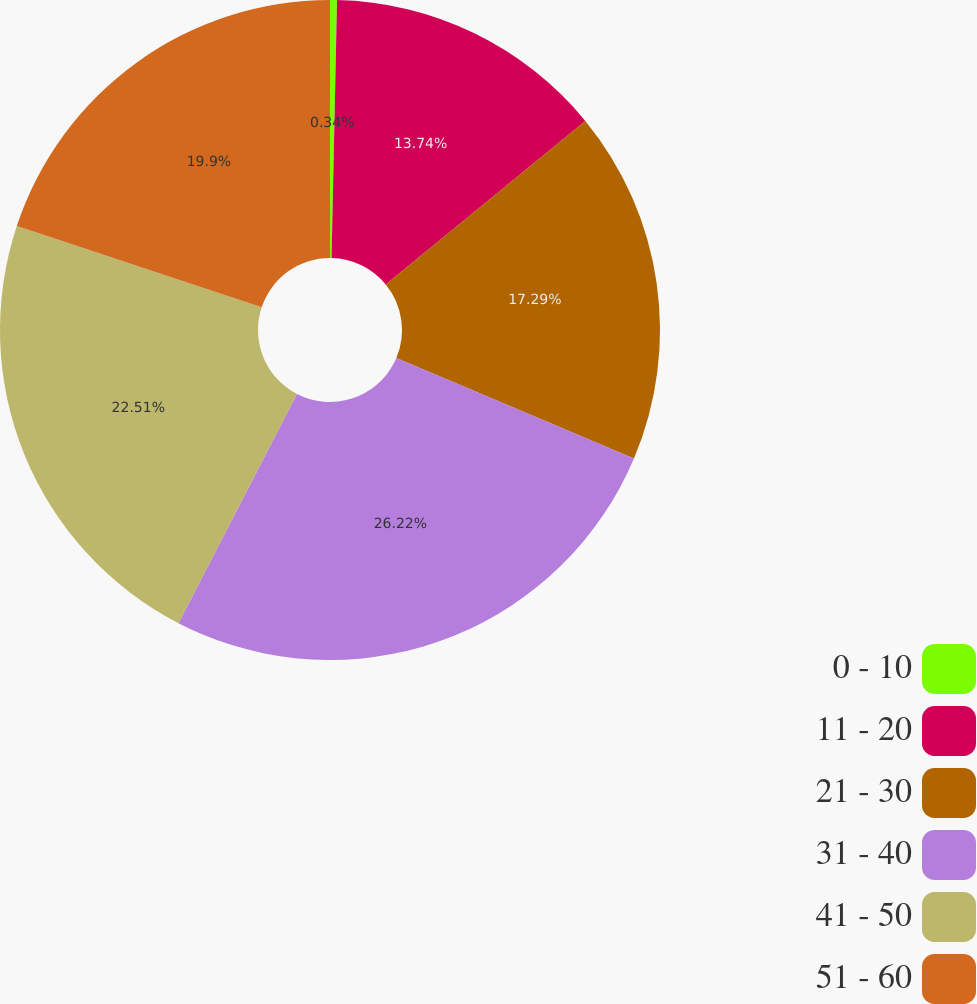Convert chart to OTSL. <chart><loc_0><loc_0><loc_500><loc_500><pie_chart><fcel>0 - 10<fcel>11 - 20<fcel>21 - 30<fcel>31 - 40<fcel>41 - 50<fcel>51 - 60<nl><fcel>0.34%<fcel>13.74%<fcel>17.29%<fcel>26.23%<fcel>22.51%<fcel>19.9%<nl></chart> 